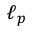Convert formula to latex. <formula><loc_0><loc_0><loc_500><loc_500>\ell _ { p }</formula> 